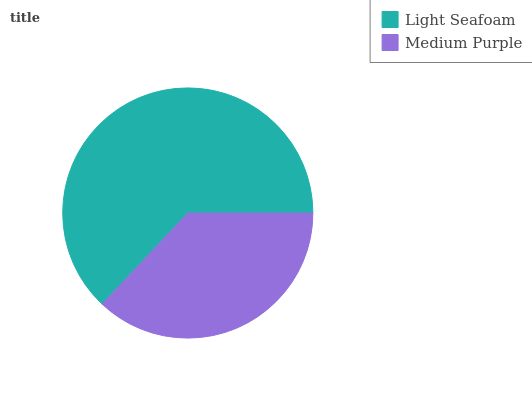Is Medium Purple the minimum?
Answer yes or no. Yes. Is Light Seafoam the maximum?
Answer yes or no. Yes. Is Medium Purple the maximum?
Answer yes or no. No. Is Light Seafoam greater than Medium Purple?
Answer yes or no. Yes. Is Medium Purple less than Light Seafoam?
Answer yes or no. Yes. Is Medium Purple greater than Light Seafoam?
Answer yes or no. No. Is Light Seafoam less than Medium Purple?
Answer yes or no. No. Is Light Seafoam the high median?
Answer yes or no. Yes. Is Medium Purple the low median?
Answer yes or no. Yes. Is Medium Purple the high median?
Answer yes or no. No. Is Light Seafoam the low median?
Answer yes or no. No. 